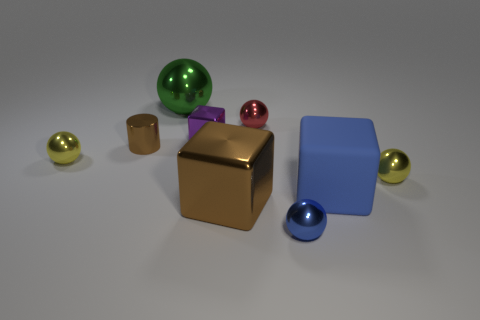Subtract all purple blocks. How many blocks are left? 2 Add 1 tiny gray blocks. How many objects exist? 10 Subtract all gray cubes. How many yellow balls are left? 2 Subtract 1 blocks. How many blocks are left? 2 Subtract all blue spheres. How many spheres are left? 4 Subtract all balls. How many objects are left? 4 Subtract all gray balls. Subtract all brown cylinders. How many balls are left? 5 Subtract all blue spheres. Subtract all small blue spheres. How many objects are left? 7 Add 6 tiny brown metallic cylinders. How many tiny brown metallic cylinders are left? 7 Add 8 big brown metallic things. How many big brown metallic things exist? 9 